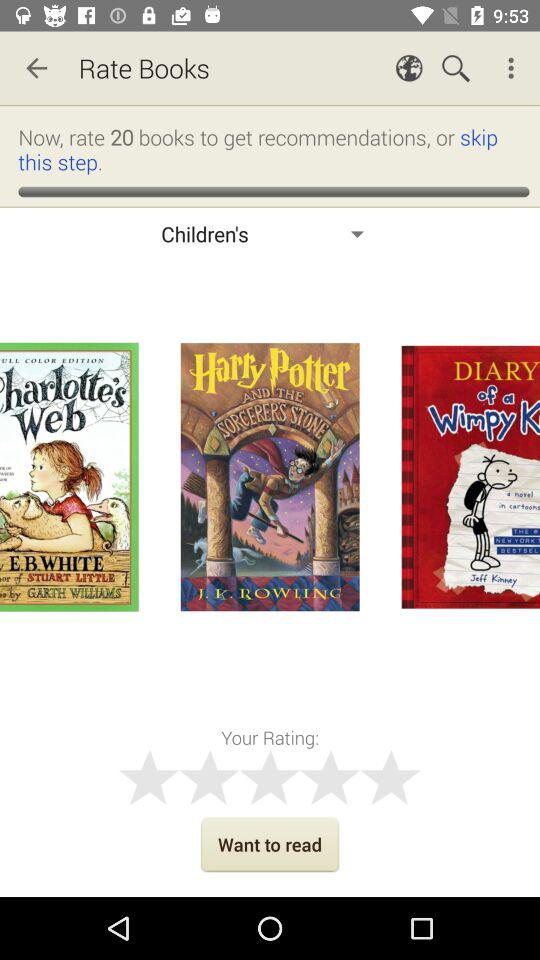How many books should be rated for the recommendations? For the recommendations, 20 books should be rated. 